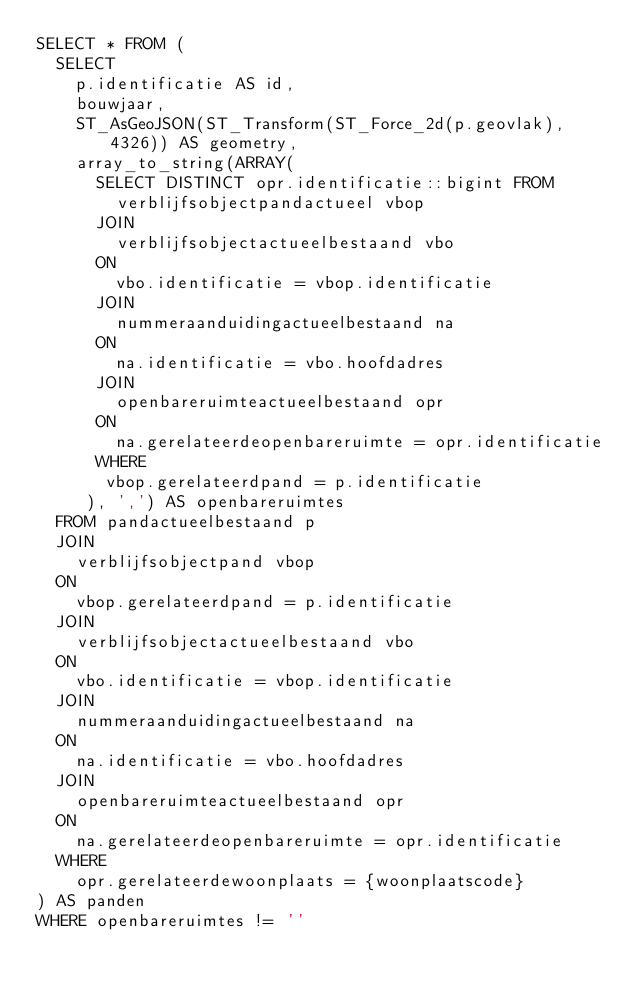Convert code to text. <code><loc_0><loc_0><loc_500><loc_500><_SQL_>SELECT * FROM (
  SELECT
    p.identificatie AS id,
    bouwjaar,
    ST_AsGeoJSON(ST_Transform(ST_Force_2d(p.geovlak), 4326)) AS geometry,
    array_to_string(ARRAY(
      SELECT DISTINCT opr.identificatie::bigint FROM
        verblijfsobjectpandactueel vbop
      JOIN
        verblijfsobjectactueelbestaand vbo
      ON
        vbo.identificatie = vbop.identificatie
      JOIN
        nummeraanduidingactueelbestaand na
      ON
        na.identificatie = vbo.hoofdadres
      JOIN
        openbareruimteactueelbestaand opr
      ON
        na.gerelateerdeopenbareruimte = opr.identificatie
      WHERE
       vbop.gerelateerdpand = p.identificatie
     ), ',') AS openbareruimtes
  FROM pandactueelbestaand p
  JOIN
    verblijfsobjectpand vbop
  ON
    vbop.gerelateerdpand = p.identificatie
  JOIN
    verblijfsobjectactueelbestaand vbo
  ON
    vbo.identificatie = vbop.identificatie
  JOIN
    nummeraanduidingactueelbestaand na
  ON
    na.identificatie = vbo.hoofdadres
  JOIN
    openbareruimteactueelbestaand opr
  ON
    na.gerelateerdeopenbareruimte = opr.identificatie
  WHERE
    opr.gerelateerdewoonplaats = {woonplaatscode}
) AS panden
WHERE openbareruimtes != ''
</code> 